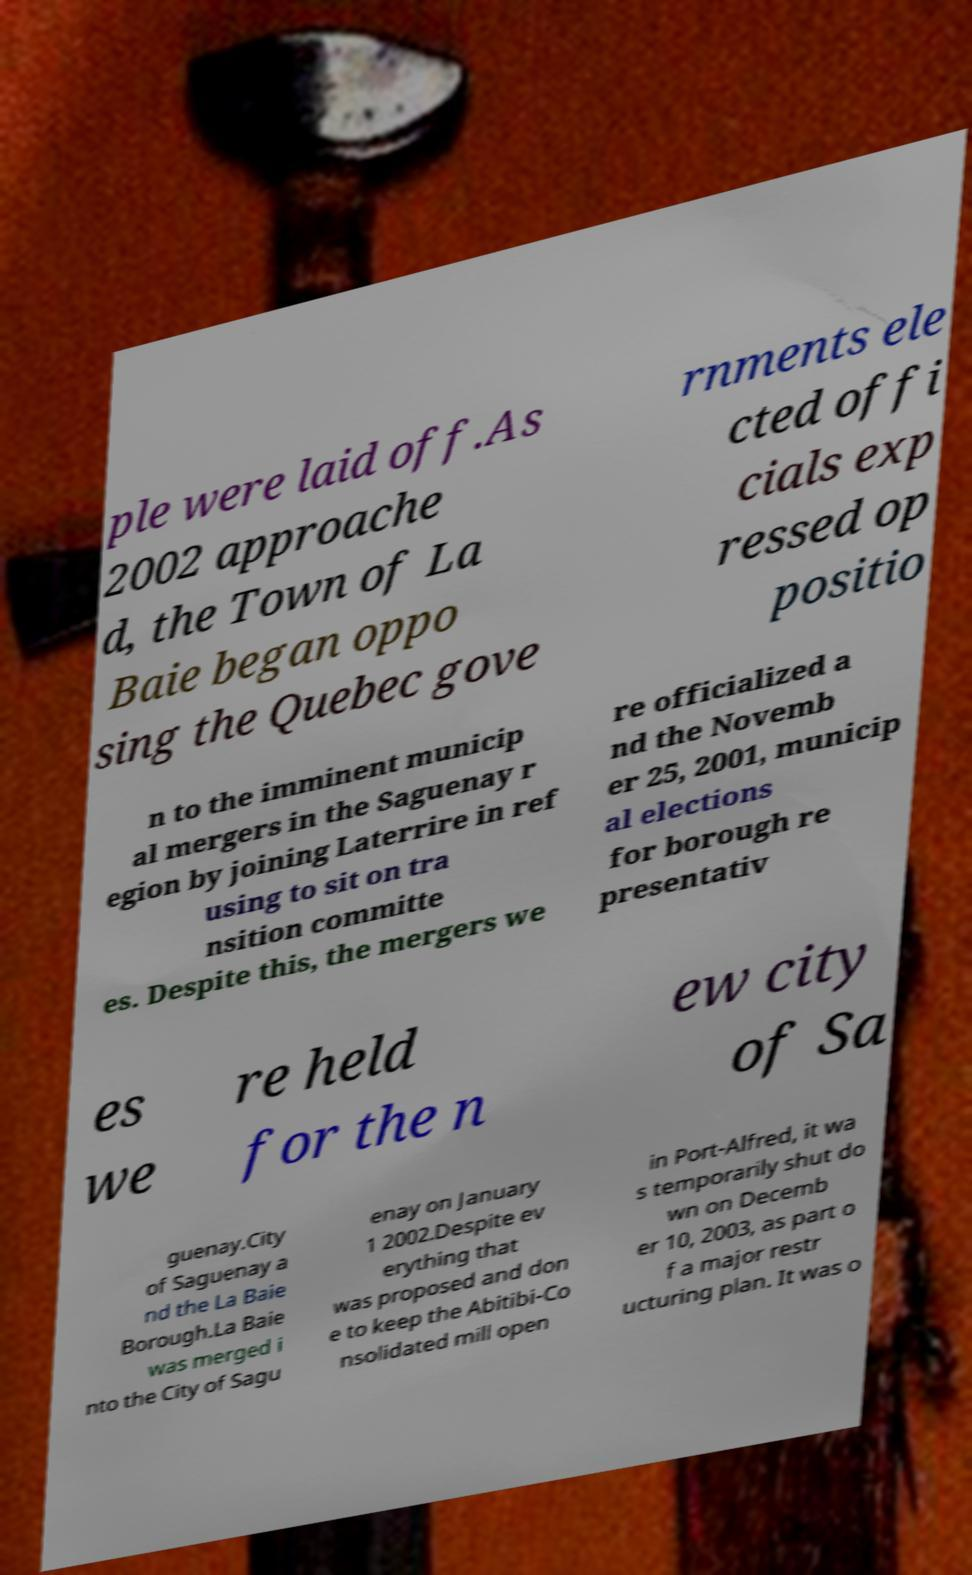What messages or text are displayed in this image? I need them in a readable, typed format. ple were laid off.As 2002 approache d, the Town of La Baie began oppo sing the Quebec gove rnments ele cted offi cials exp ressed op positio n to the imminent municip al mergers in the Saguenay r egion by joining Laterrire in ref using to sit on tra nsition committe es. Despite this, the mergers we re officialized a nd the Novemb er 25, 2001, municip al elections for borough re presentativ es we re held for the n ew city of Sa guenay.City of Saguenay a nd the La Baie Borough.La Baie was merged i nto the City of Sagu enay on January 1 2002.Despite ev erything that was proposed and don e to keep the Abitibi-Co nsolidated mill open in Port-Alfred, it wa s temporarily shut do wn on Decemb er 10, 2003, as part o f a major restr ucturing plan. It was o 